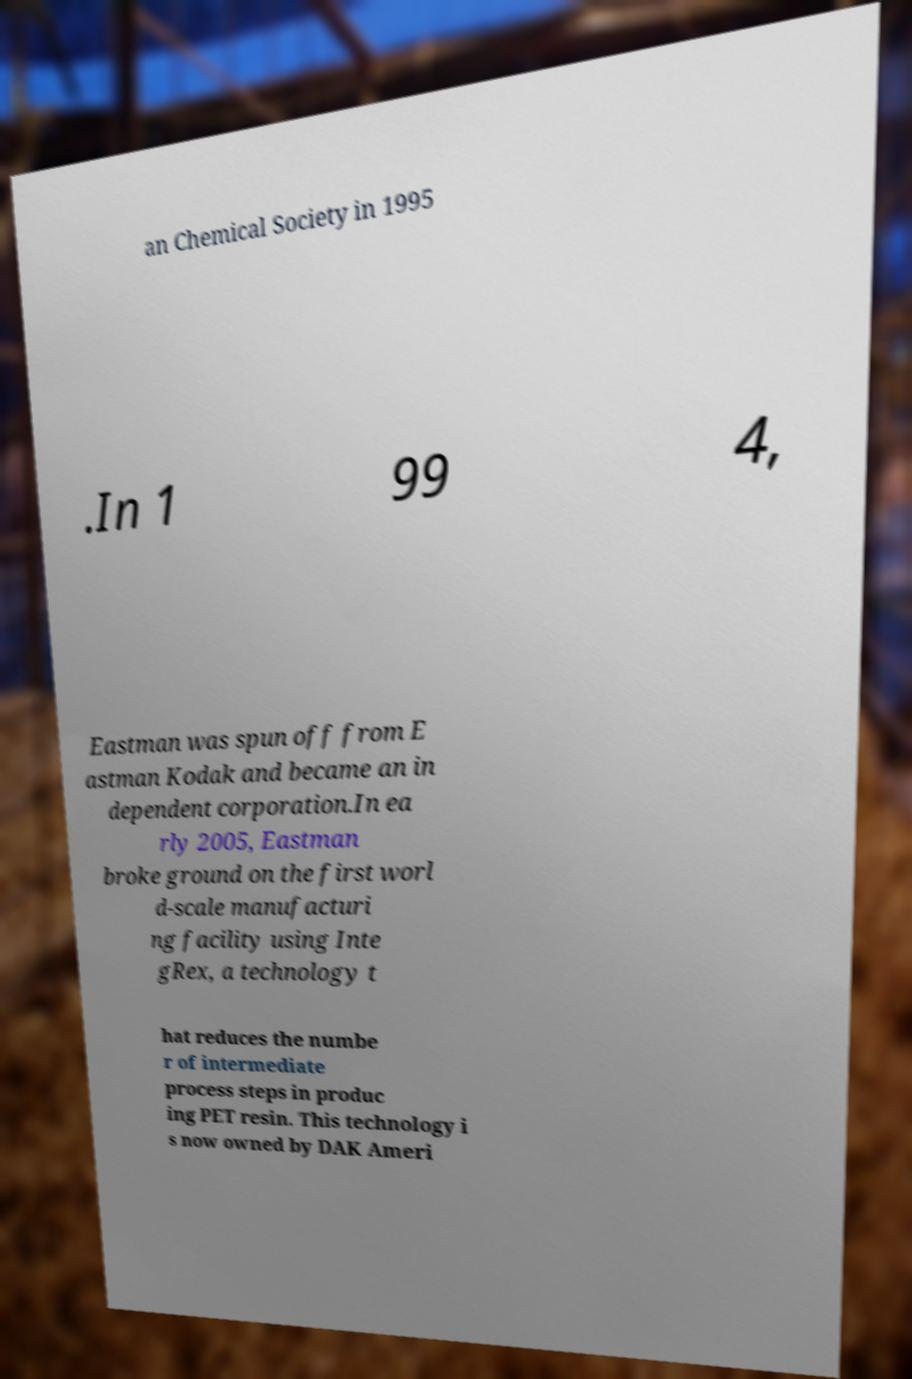I need the written content from this picture converted into text. Can you do that? an Chemical Society in 1995 .In 1 99 4, Eastman was spun off from E astman Kodak and became an in dependent corporation.In ea rly 2005, Eastman broke ground on the first worl d-scale manufacturi ng facility using Inte gRex, a technology t hat reduces the numbe r of intermediate process steps in produc ing PET resin. This technology i s now owned by DAK Ameri 